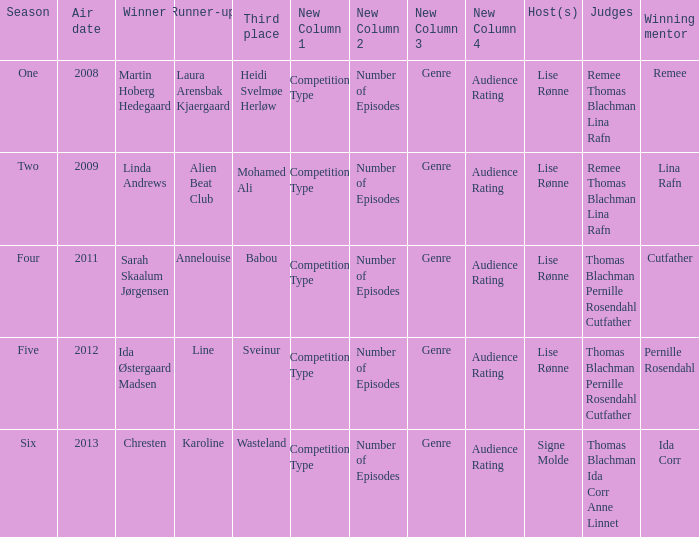Who was the runner-up in season five? Line. 